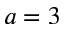Convert formula to latex. <formula><loc_0><loc_0><loc_500><loc_500>a = 3</formula> 